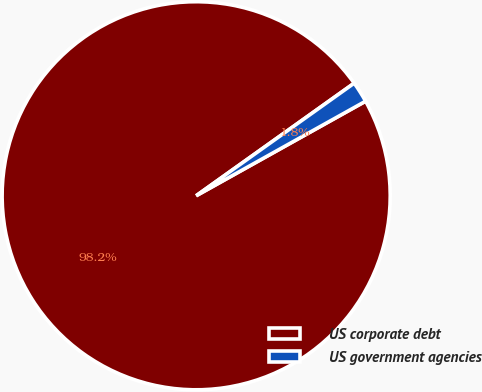<chart> <loc_0><loc_0><loc_500><loc_500><pie_chart><fcel>US corporate debt<fcel>US government agencies<nl><fcel>98.25%<fcel>1.75%<nl></chart> 